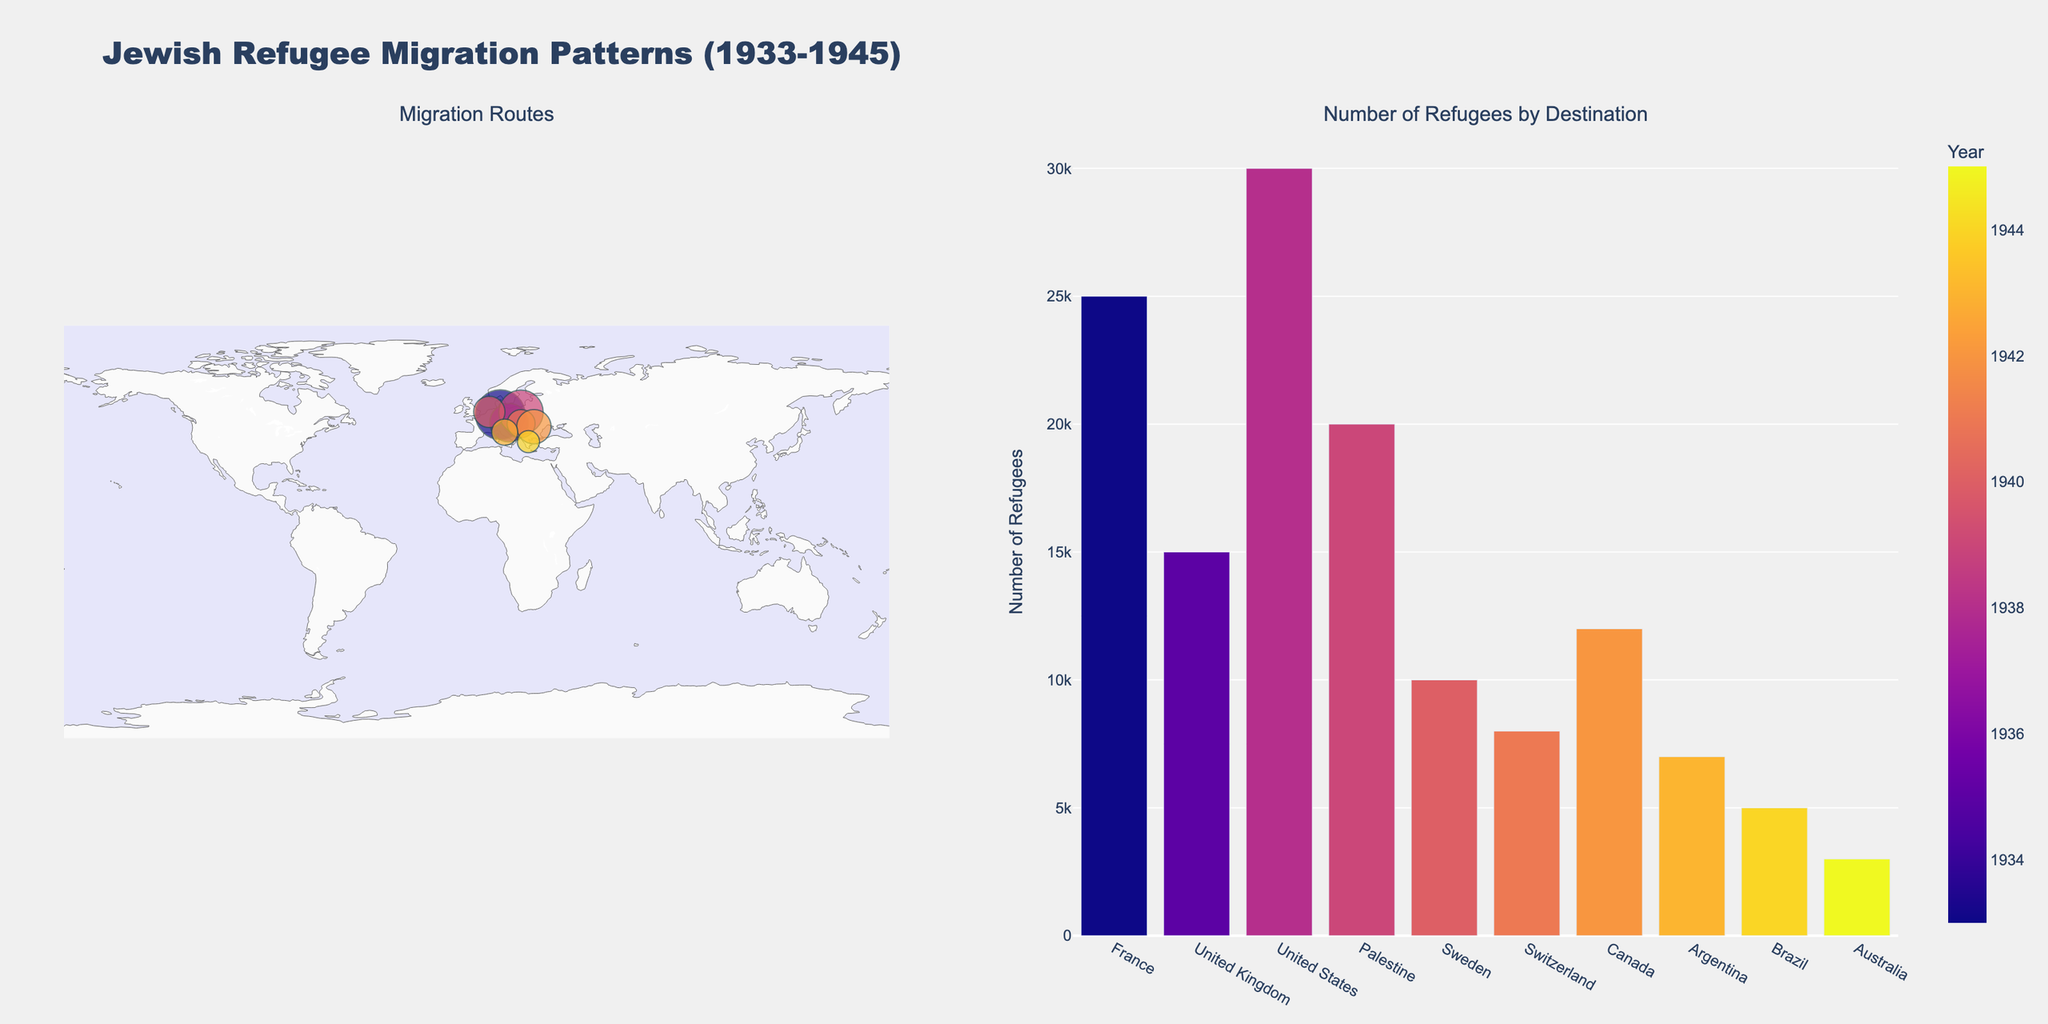What is the title of the plot? The title of the plot is displayed at the top of the figure. It reads "Jewish Refugee Migration Patterns (1933-1945)."
Answer: Jewish Refugee Migration Patterns (1933-1945) Which country has the highest number of refugees recorded and how many? Looking at the bar chart on the right, we identify the country with the tallest bar, which is the United States. The y-axis value indicates 30,000 refugees.
Answer: United States, 30,000 Which year had the largest migration event and from which country to which country? By observing the scatter geo plot and noting the size of the markers, the year 1938 stands out. The migration was from Czechoslovakia to the United States, indicating the largest movement with 30,000 refugees.
Answer: 1938, Czechoslovakia to United States What's the total number of refugees who migrated to South American countries and which countries are they? Referring to the bar chart, the number of refugees who migrated to South American countries are from Argentina and Brazil. Summing Argentina (7,000) and Brazil (5,000) gives a total of 12,000.
Answer: 12,000, Argentina and Brazil Compare the number of refugees fleeing from Austria and Germany. Which country had more and by how many? From the scatter geo plot and bar chart, Austria had 15,000 refugees, while Germany had 25,000 refugees. The difference is calculated as 25,000 - 15,000 = 10,000.
Answer: Germany had more, by 10,000 What are the destinations of refugees who fled Eastern European countries? Observing the geographic plot for the origins and matching them with Eastern European countries, the destinations are: Palestine (from Poland), Sweden (from Netherlands), Switzerland (from Hungary), Canada (from Romania).
Answer: Palestine, Sweden, Switzerland, Canada Which geographic region received the least number of refugees and what is that number? From the bar chart, Australia has the shortest bar graph indicating it received the least number of refugees, which is 3,000.
Answer: Australia, 3,000 Identify the years during which refugees fled to non-European countries. By examining the color-coded bar chart by year and mapping it to the destination countries, the non-European countries destinations occurred in 1938 (United States), 1942 (Canada), 1943 (Argentina), 1944 (Brazil), 1945 (Australia).
Answer: 1938, 1942, 1943, 1944, 1945 